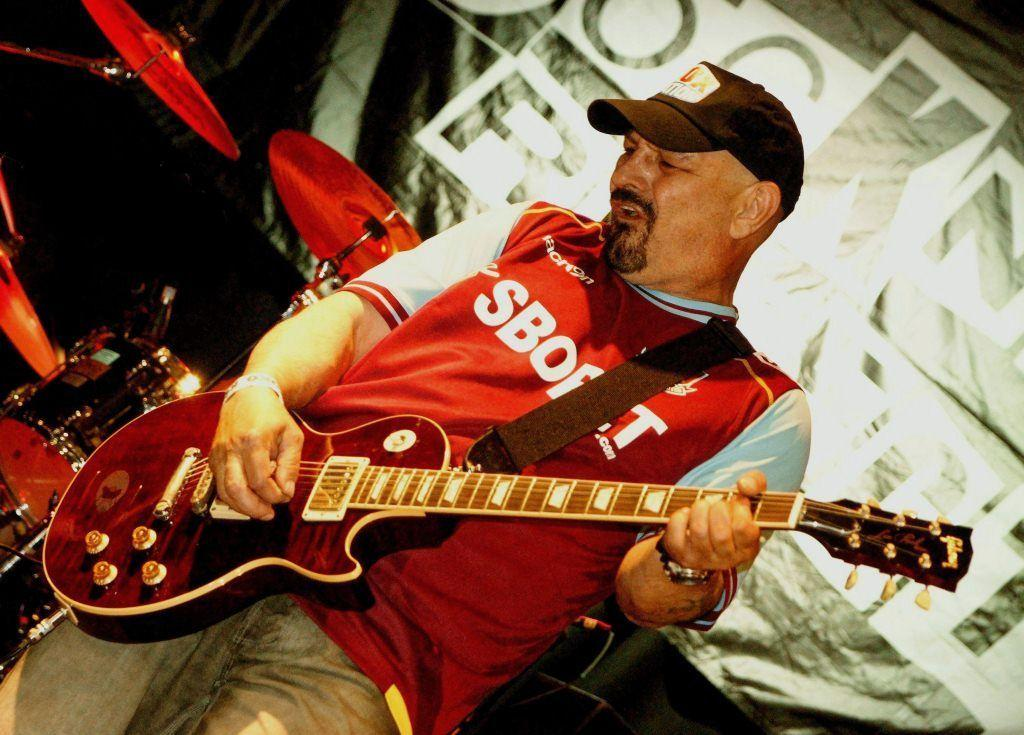What is the person in the image doing? The person is playing a guitar in the image. What other objects are related to music in the image? There are musical instruments in the image. What can be seen in the background of the image? There is a banner in the background of the image. What type of jewel is the person wearing on their head in the image? There is no jewel visible on the person's head in the image. How does the crook affect the person playing the guitar in the image? There is no crook present in the image, so it cannot affect the person playing the guitar. 